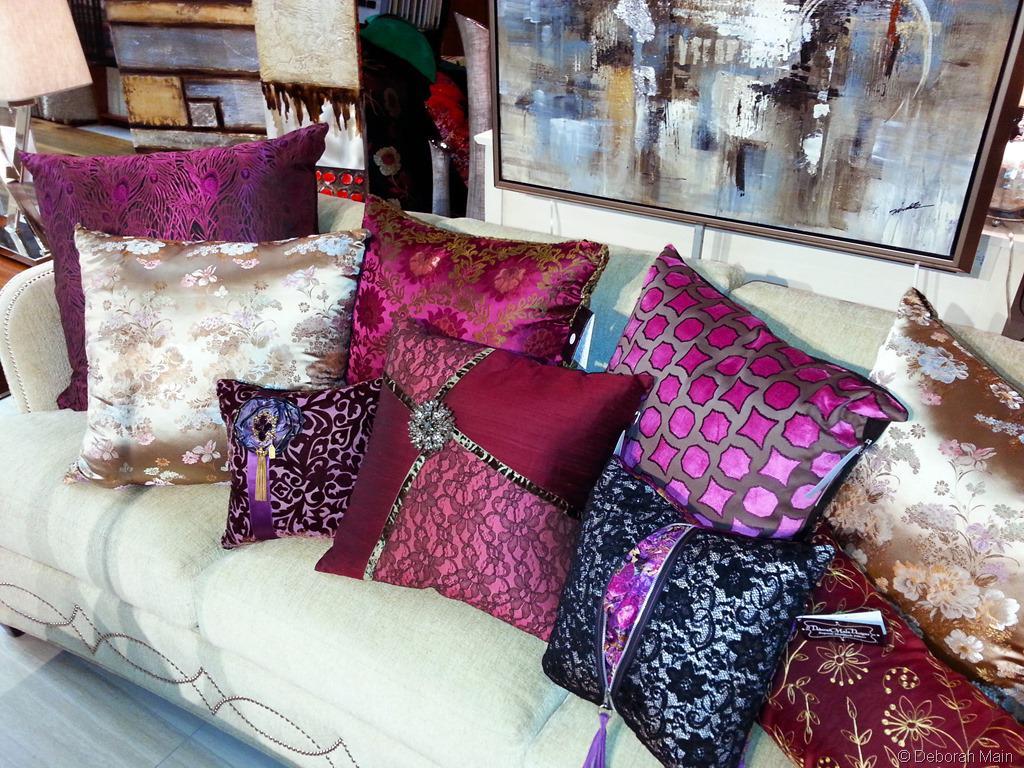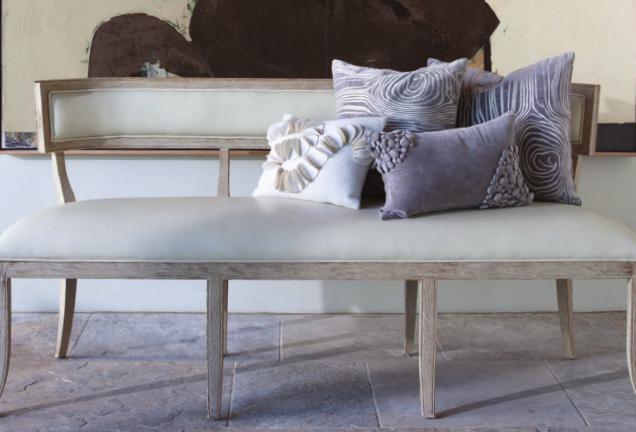The first image is the image on the left, the second image is the image on the right. Evaluate the accuracy of this statement regarding the images: "One image features at least one pillow with button closures, and the other image contains at least 7 square pillows of different colors.". Is it true? Answer yes or no. No. The first image is the image on the left, the second image is the image on the right. Considering the images on both sides, is "Two different colored pillows are stacked horizontally on a floor beside no more than two other different colored pillows." valid? Answer yes or no. No. 